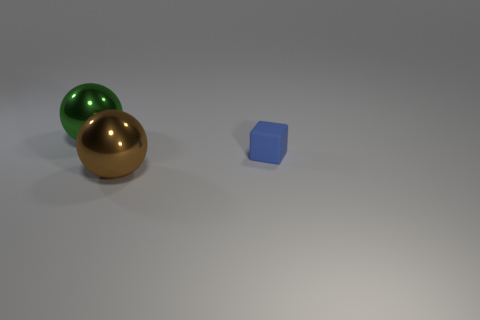Add 2 tiny green objects. How many objects exist? 5 Subtract all brown spheres. How many spheres are left? 1 Subtract 1 cubes. How many cubes are left? 0 Subtract all yellow blocks. How many brown balls are left? 1 Subtract all yellow spheres. Subtract all brown cylinders. How many spheres are left? 2 Subtract all tiny blue spheres. Subtract all tiny blocks. How many objects are left? 2 Add 3 tiny blue rubber blocks. How many tiny blue rubber blocks are left? 4 Add 2 brown things. How many brown things exist? 3 Subtract 0 purple spheres. How many objects are left? 3 Subtract all balls. How many objects are left? 1 